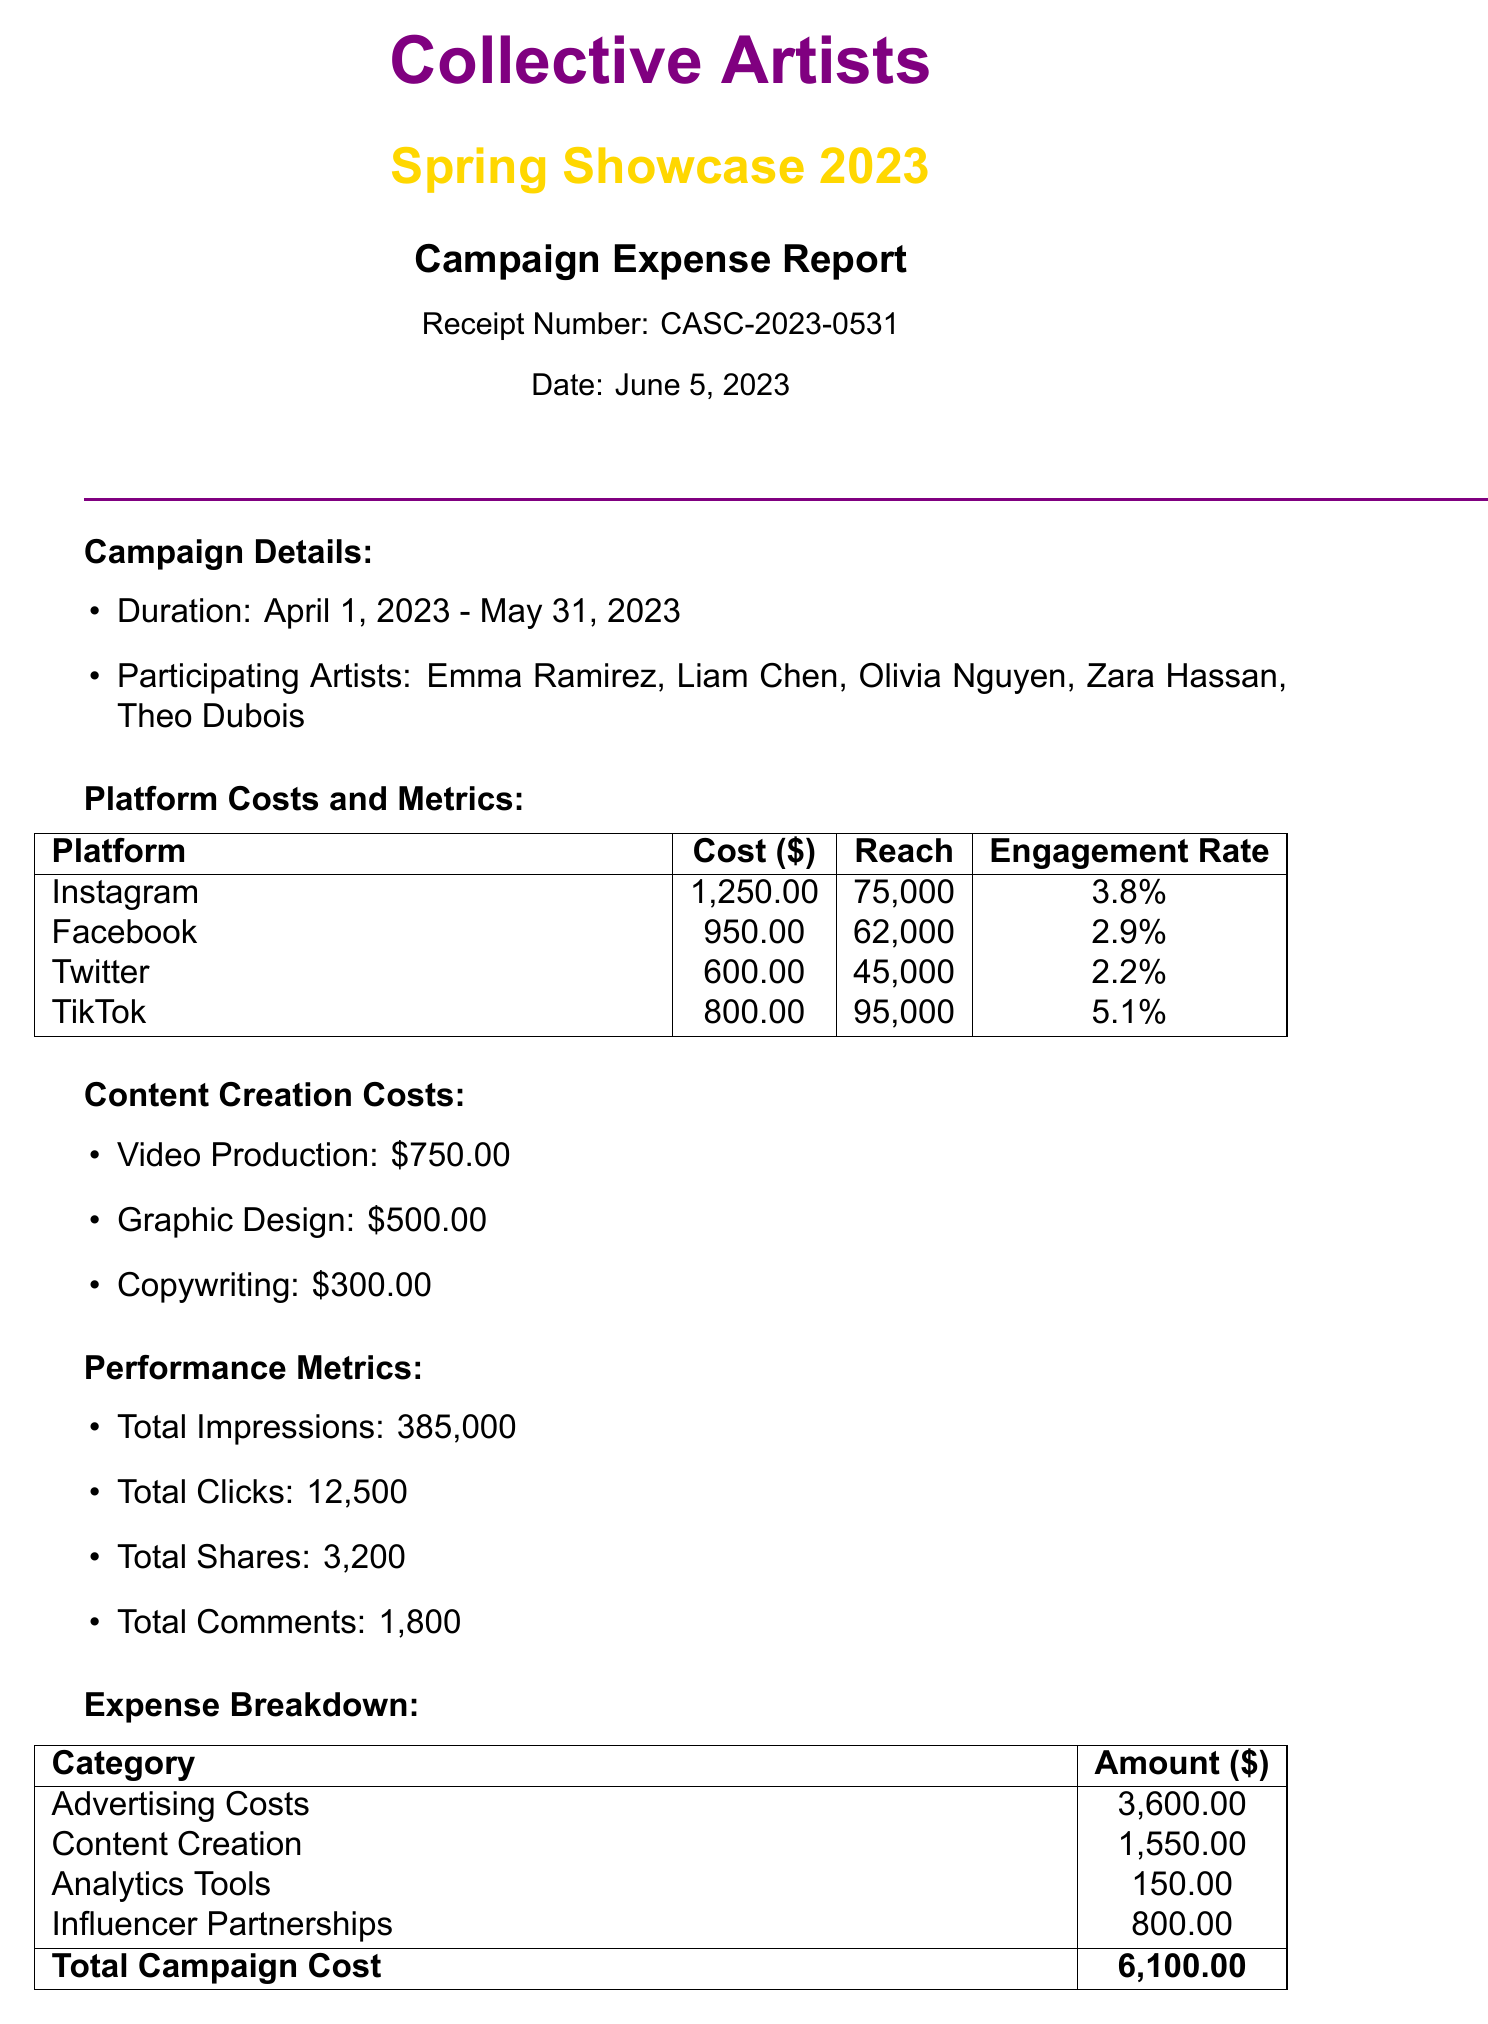what is the campaign name? The campaign name is stated at the beginning of the document.
Answer: Collective Artists Spring Showcase 2023 what is the duration of the campaign? The duration of the campaign is specified in the details section of the document.
Answer: April 1, 2023 - May 31, 2023 how much was spent on Instagram? The total cost for Instagram advertising is listed in the platform costs section.
Answer: 1250.00 what was the engagement rate on TikTok? The engagement rate for TikTok is provided in the platform costs and metrics table.
Answer: 5.1% what is the total amount for advertising costs? The total amount for advertising costs is detailed in the expense breakdown table of the document.
Answer: 3600.00 how many total clicks were generated? The total number of clicks is found in the performance metrics section of the document.
Answer: 12500 what is the cost per artist? The document specifies the cost per artist in the expense breakdown section.
Answer: 1220.00 what payment method was used for expenses? The payment method is specified in the expense report details.
Answer: Shared expense card (Collective Artists Fund) 